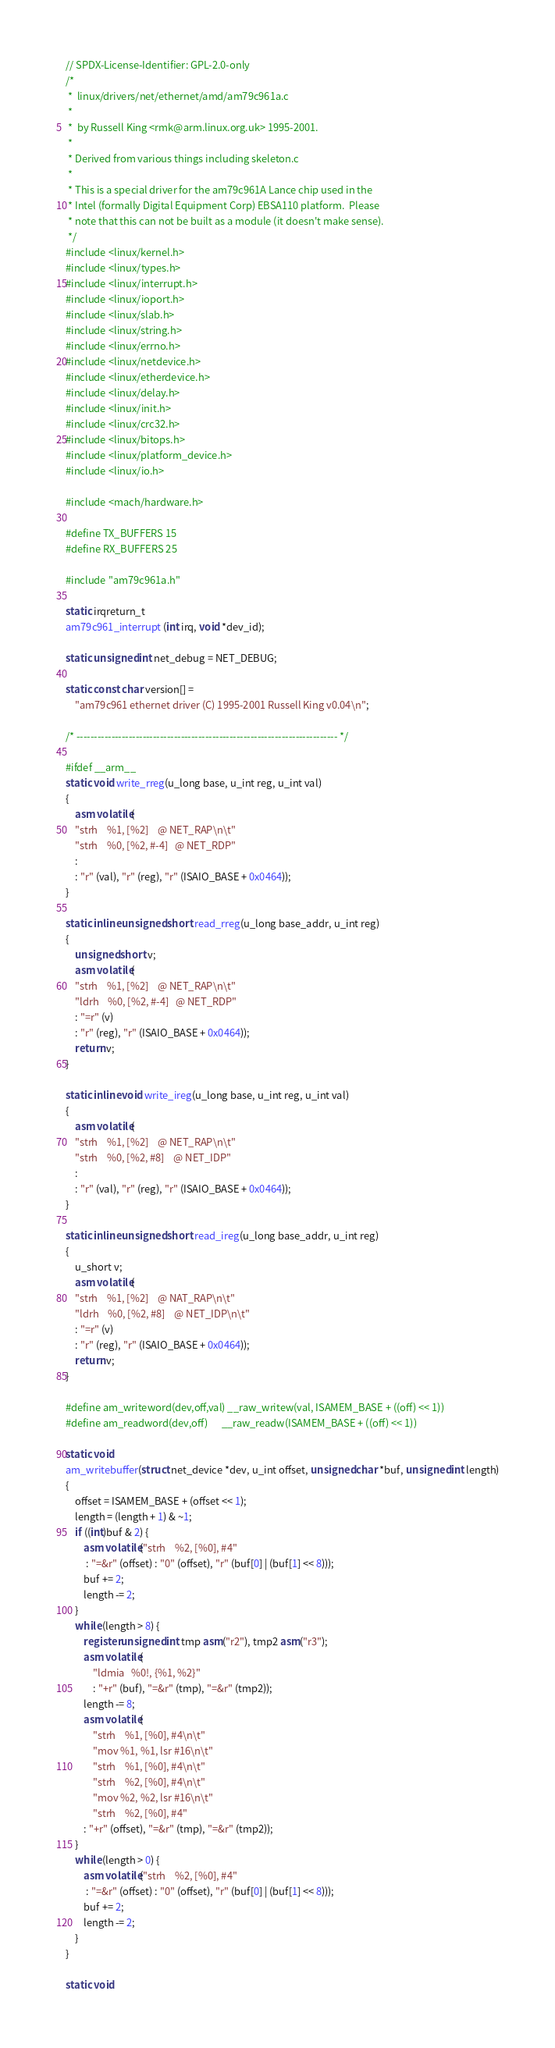<code> <loc_0><loc_0><loc_500><loc_500><_C_>// SPDX-License-Identifier: GPL-2.0-only
/*
 *  linux/drivers/net/ethernet/amd/am79c961a.c
 *
 *  by Russell King <rmk@arm.linux.org.uk> 1995-2001.
 *
 * Derived from various things including skeleton.c
 *
 * This is a special driver for the am79c961A Lance chip used in the
 * Intel (formally Digital Equipment Corp) EBSA110 platform.  Please
 * note that this can not be built as a module (it doesn't make sense).
 */
#include <linux/kernel.h>
#include <linux/types.h>
#include <linux/interrupt.h>
#include <linux/ioport.h>
#include <linux/slab.h>
#include <linux/string.h>
#include <linux/errno.h>
#include <linux/netdevice.h>
#include <linux/etherdevice.h>
#include <linux/delay.h>
#include <linux/init.h>
#include <linux/crc32.h>
#include <linux/bitops.h>
#include <linux/platform_device.h>
#include <linux/io.h>

#include <mach/hardware.h>

#define TX_BUFFERS 15
#define RX_BUFFERS 25

#include "am79c961a.h"

static irqreturn_t
am79c961_interrupt (int irq, void *dev_id);

static unsigned int net_debug = NET_DEBUG;

static const char version[] =
	"am79c961 ethernet driver (C) 1995-2001 Russell King v0.04\n";

/* --------------------------------------------------------------------------- */

#ifdef __arm__
static void write_rreg(u_long base, u_int reg, u_int val)
{
	asm volatile(
	"strh	%1, [%2]	@ NET_RAP\n\t"
	"strh	%0, [%2, #-4]	@ NET_RDP"
	:
	: "r" (val), "r" (reg), "r" (ISAIO_BASE + 0x0464));
}

static inline unsigned short read_rreg(u_long base_addr, u_int reg)
{
	unsigned short v;
	asm volatile(
	"strh	%1, [%2]	@ NET_RAP\n\t"
	"ldrh	%0, [%2, #-4]	@ NET_RDP"
	: "=r" (v)
	: "r" (reg), "r" (ISAIO_BASE + 0x0464));
	return v;
}

static inline void write_ireg(u_long base, u_int reg, u_int val)
{
	asm volatile(
	"strh	%1, [%2]	@ NET_RAP\n\t"
	"strh	%0, [%2, #8]	@ NET_IDP"
	:
	: "r" (val), "r" (reg), "r" (ISAIO_BASE + 0x0464));
}

static inline unsigned short read_ireg(u_long base_addr, u_int reg)
{
	u_short v;
	asm volatile(
	"strh	%1, [%2]	@ NAT_RAP\n\t"
	"ldrh	%0, [%2, #8]	@ NET_IDP\n\t"
	: "=r" (v)
	: "r" (reg), "r" (ISAIO_BASE + 0x0464));
	return v;
}

#define am_writeword(dev,off,val) __raw_writew(val, ISAMEM_BASE + ((off) << 1))
#define am_readword(dev,off)      __raw_readw(ISAMEM_BASE + ((off) << 1))

static void
am_writebuffer(struct net_device *dev, u_int offset, unsigned char *buf, unsigned int length)
{
	offset = ISAMEM_BASE + (offset << 1);
	length = (length + 1) & ~1;
	if ((int)buf & 2) {
		asm volatile("strh	%2, [%0], #4"
		 : "=&r" (offset) : "0" (offset), "r" (buf[0] | (buf[1] << 8)));
		buf += 2;
		length -= 2;
	}
	while (length > 8) {
		register unsigned int tmp asm("r2"), tmp2 asm("r3");
		asm volatile(
			"ldmia	%0!, {%1, %2}"
			: "+r" (buf), "=&r" (tmp), "=&r" (tmp2));
		length -= 8;
		asm volatile(
			"strh	%1, [%0], #4\n\t"
			"mov	%1, %1, lsr #16\n\t"
			"strh	%1, [%0], #4\n\t"
			"strh	%2, [%0], #4\n\t"
			"mov	%2, %2, lsr #16\n\t"
			"strh	%2, [%0], #4"
		: "+r" (offset), "=&r" (tmp), "=&r" (tmp2));
	}
	while (length > 0) {
		asm volatile("strh	%2, [%0], #4"
		 : "=&r" (offset) : "0" (offset), "r" (buf[0] | (buf[1] << 8)));
		buf += 2;
		length -= 2;
	}
}

static void</code> 